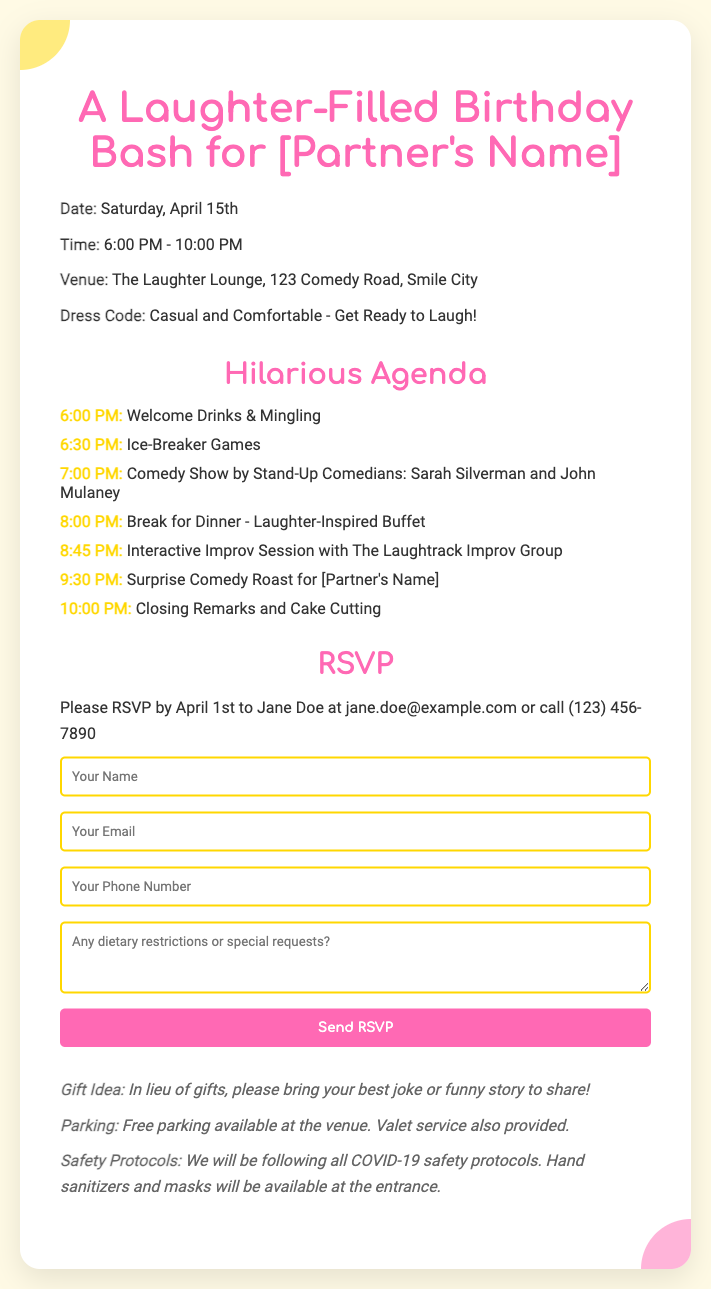What is the date of the birthday bash? The date is clearly stated in the event details section of the document.
Answer: Saturday, April 15th What time does the comedy show start? The schedule in the agenda outlines the start time for the comedy show.
Answer: 7:00 PM Who are the comedians performing? The comedians are listed in the agenda section of the document.
Answer: Sarah Silverman and John Mulaney What should guests bring instead of gifts? The additional information provides a specific request for guests.
Answer: Their best joke or funny story By when should guests RSVP? The RSVP details section specifies the deadline for responses.
Answer: April 1st What is the dress code for the event? The dress code is mentioned in the event details section.
Answer: Casual and Comfortable What type of buffet will be served? The agenda mentions the theme of the dinner to be served.
Answer: Laughter-Inspired Buffet What is provided for parking at the venue? The additional info section states the parking arrangements.
Answer: Free parking What safety protocols will be followed? The additional info section specifies the safety measures in place.
Answer: COVID-19 safety protocols 